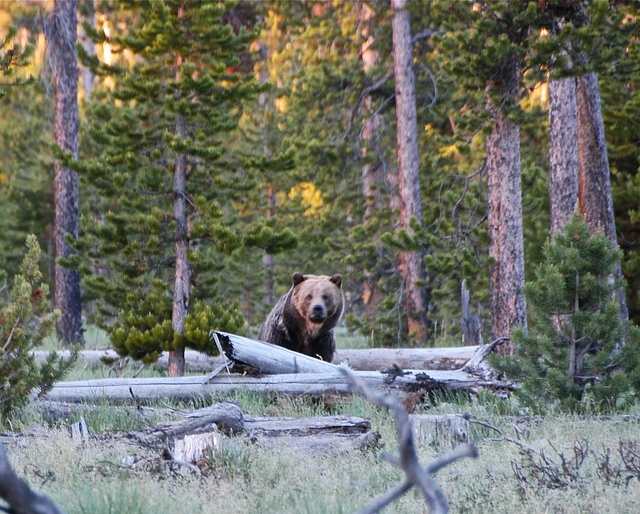Describe the objects in this image and their specific colors. I can see a bear in tan, black, gray, and darkgray tones in this image. 